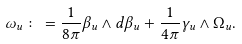Convert formula to latex. <formula><loc_0><loc_0><loc_500><loc_500>\omega _ { u } \colon = \frac { 1 } { 8 \pi } \beta _ { u } \wedge d \beta _ { u } + \frac { 1 } { 4 \pi } \gamma _ { u } \wedge \Omega _ { u } .</formula> 